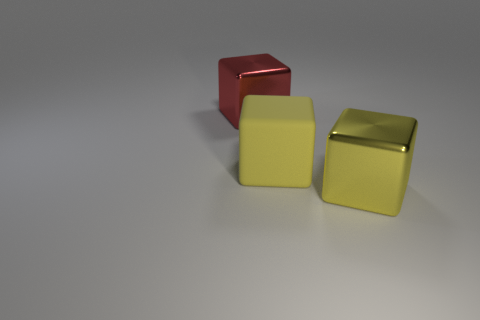Subtract all brown spheres. How many yellow cubes are left? 2 Add 2 big yellow shiny cubes. How many objects exist? 5 Subtract all big red shiny blocks. How many blocks are left? 2 Subtract 1 cubes. How many cubes are left? 2 Add 1 big rubber things. How many big rubber things are left? 2 Add 1 tiny blue balls. How many tiny blue balls exist? 1 Subtract 1 red cubes. How many objects are left? 2 Subtract all yellow cubes. Subtract all green cylinders. How many cubes are left? 1 Subtract all large cyan cylinders. Subtract all rubber objects. How many objects are left? 2 